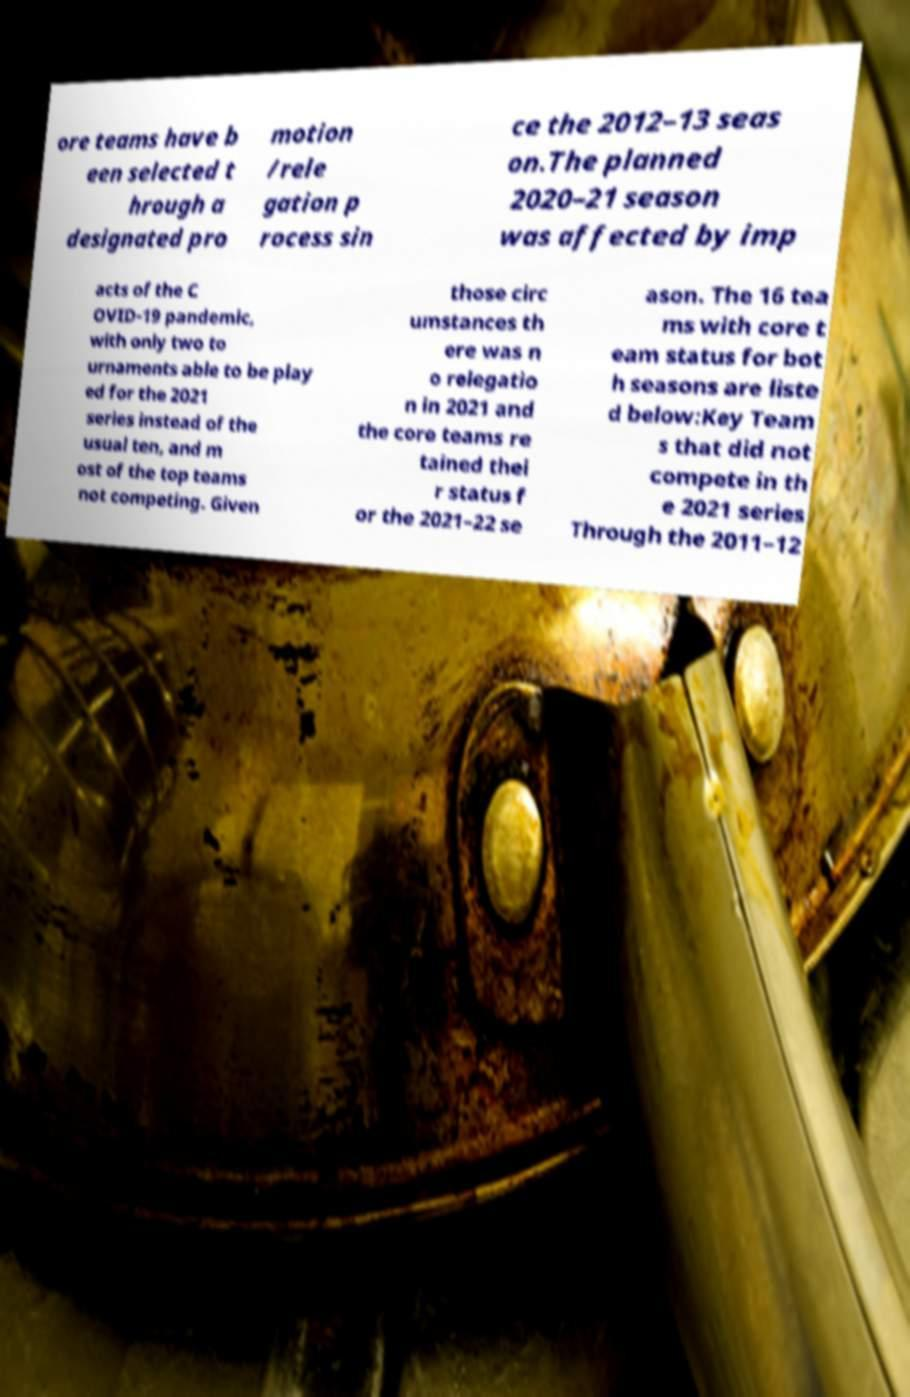What messages or text are displayed in this image? I need them in a readable, typed format. ore teams have b een selected t hrough a designated pro motion /rele gation p rocess sin ce the 2012–13 seas on.The planned 2020–21 season was affected by imp acts of the C OVID-19 pandemic, with only two to urnaments able to be play ed for the 2021 series instead of the usual ten, and m ost of the top teams not competing. Given those circ umstances th ere was n o relegatio n in 2021 and the core teams re tained thei r status f or the 2021–22 se ason. The 16 tea ms with core t eam status for bot h seasons are liste d below:Key Team s that did not compete in th e 2021 series Through the 2011–12 